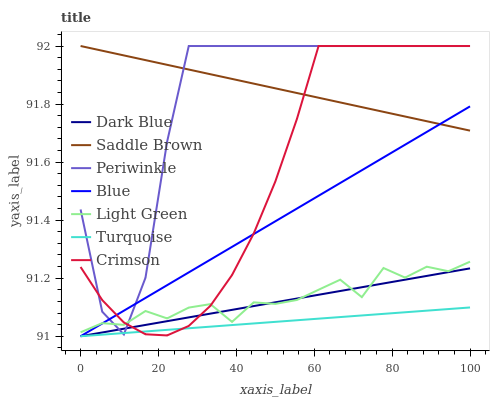Does Turquoise have the minimum area under the curve?
Answer yes or no. Yes. Does Saddle Brown have the maximum area under the curve?
Answer yes or no. Yes. Does Dark Blue have the minimum area under the curve?
Answer yes or no. No. Does Dark Blue have the maximum area under the curve?
Answer yes or no. No. Is Blue the smoothest?
Answer yes or no. Yes. Is Periwinkle the roughest?
Answer yes or no. Yes. Is Turquoise the smoothest?
Answer yes or no. No. Is Turquoise the roughest?
Answer yes or no. No. Does Blue have the lowest value?
Answer yes or no. Yes. Does Periwinkle have the lowest value?
Answer yes or no. No. Does Saddle Brown have the highest value?
Answer yes or no. Yes. Does Dark Blue have the highest value?
Answer yes or no. No. Is Light Green less than Saddle Brown?
Answer yes or no. Yes. Is Light Green greater than Turquoise?
Answer yes or no. Yes. Does Turquoise intersect Crimson?
Answer yes or no. Yes. Is Turquoise less than Crimson?
Answer yes or no. No. Is Turquoise greater than Crimson?
Answer yes or no. No. Does Light Green intersect Saddle Brown?
Answer yes or no. No. 